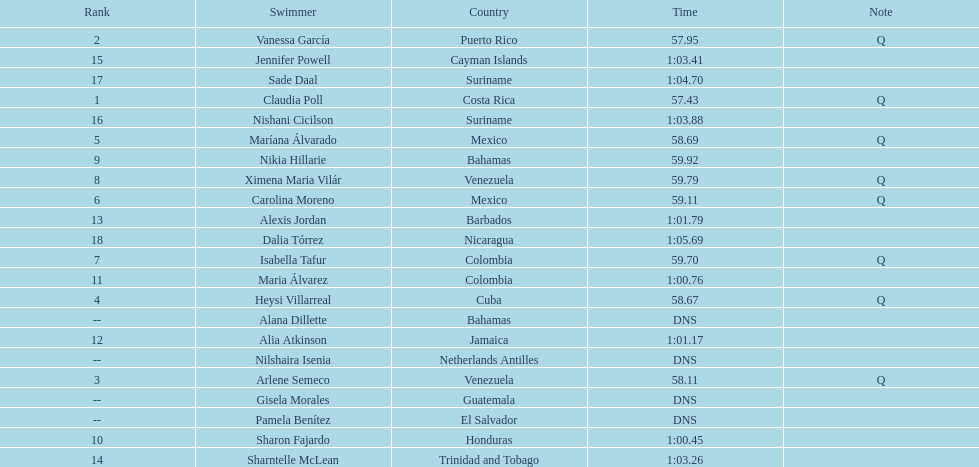What was claudia roll's time? 57.43. Parse the table in full. {'header': ['Rank', 'Swimmer', 'Country', 'Time', 'Note'], 'rows': [['2', 'Vanessa García', 'Puerto Rico', '57.95', 'Q'], ['15', 'Jennifer Powell', 'Cayman Islands', '1:03.41', ''], ['17', 'Sade Daal', 'Suriname', '1:04.70', ''], ['1', 'Claudia Poll', 'Costa Rica', '57.43', 'Q'], ['16', 'Nishani Cicilson', 'Suriname', '1:03.88', ''], ['5', 'Maríana Álvarado', 'Mexico', '58.69', 'Q'], ['9', 'Nikia Hillarie', 'Bahamas', '59.92', ''], ['8', 'Ximena Maria Vilár', 'Venezuela', '59.79', 'Q'], ['6', 'Carolina Moreno', 'Mexico', '59.11', 'Q'], ['13', 'Alexis Jordan', 'Barbados', '1:01.79', ''], ['18', 'Dalia Tórrez', 'Nicaragua', '1:05.69', ''], ['7', 'Isabella Tafur', 'Colombia', '59.70', 'Q'], ['11', 'Maria Álvarez', 'Colombia', '1:00.76', ''], ['4', 'Heysi Villarreal', 'Cuba', '58.67', 'Q'], ['--', 'Alana Dillette', 'Bahamas', 'DNS', ''], ['12', 'Alia Atkinson', 'Jamaica', '1:01.17', ''], ['--', 'Nilshaira Isenia', 'Netherlands Antilles', 'DNS', ''], ['3', 'Arlene Semeco', 'Venezuela', '58.11', 'Q'], ['--', 'Gisela Morales', 'Guatemala', 'DNS', ''], ['--', 'Pamela Benítez', 'El Salvador', 'DNS', ''], ['10', 'Sharon Fajardo', 'Honduras', '1:00.45', ''], ['14', 'Sharntelle McLean', 'Trinidad and Tobago', '1:03.26', '']]} 